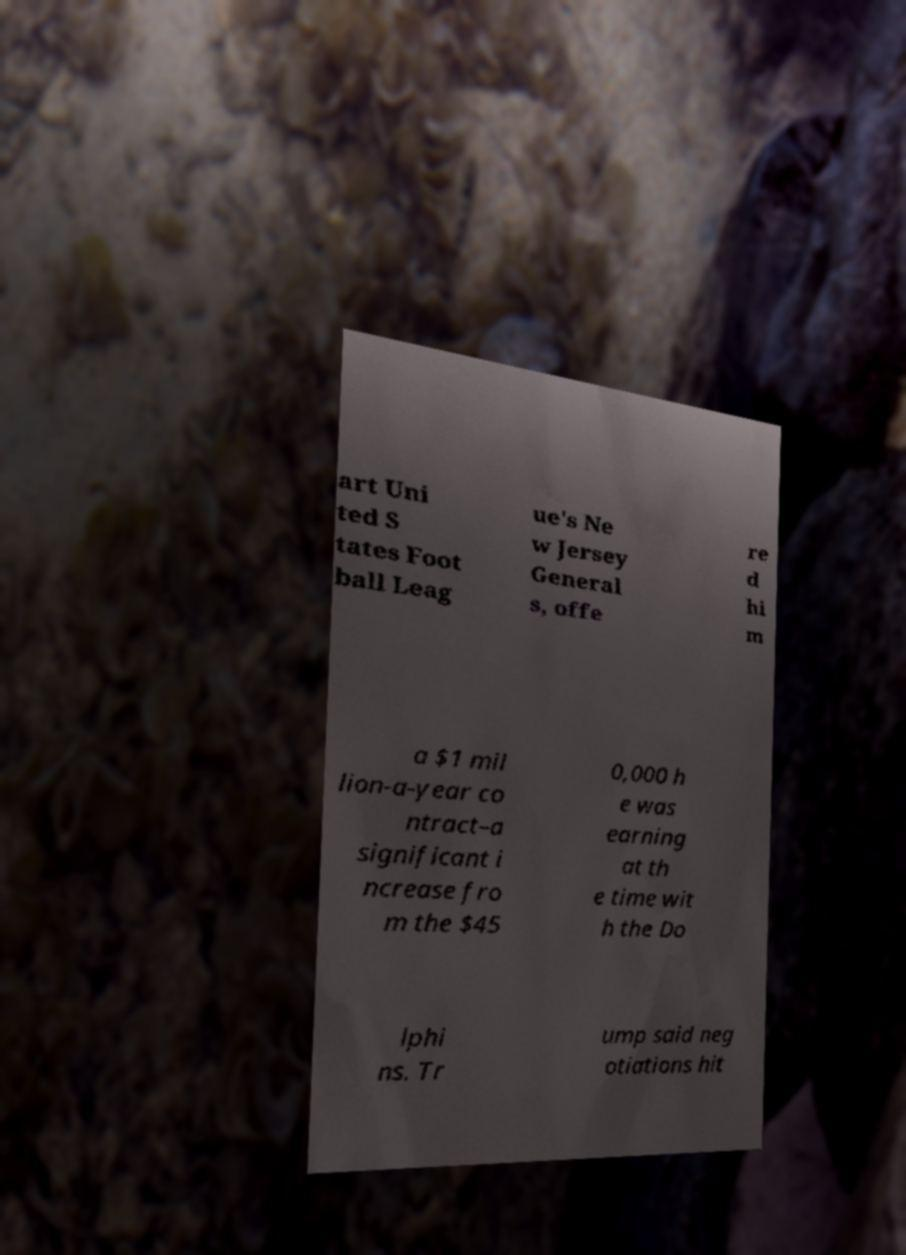There's text embedded in this image that I need extracted. Can you transcribe it verbatim? art Uni ted S tates Foot ball Leag ue's Ne w Jersey General s, offe re d hi m a $1 mil lion-a-year co ntract–a significant i ncrease fro m the $45 0,000 h e was earning at th e time wit h the Do lphi ns. Tr ump said neg otiations hit 